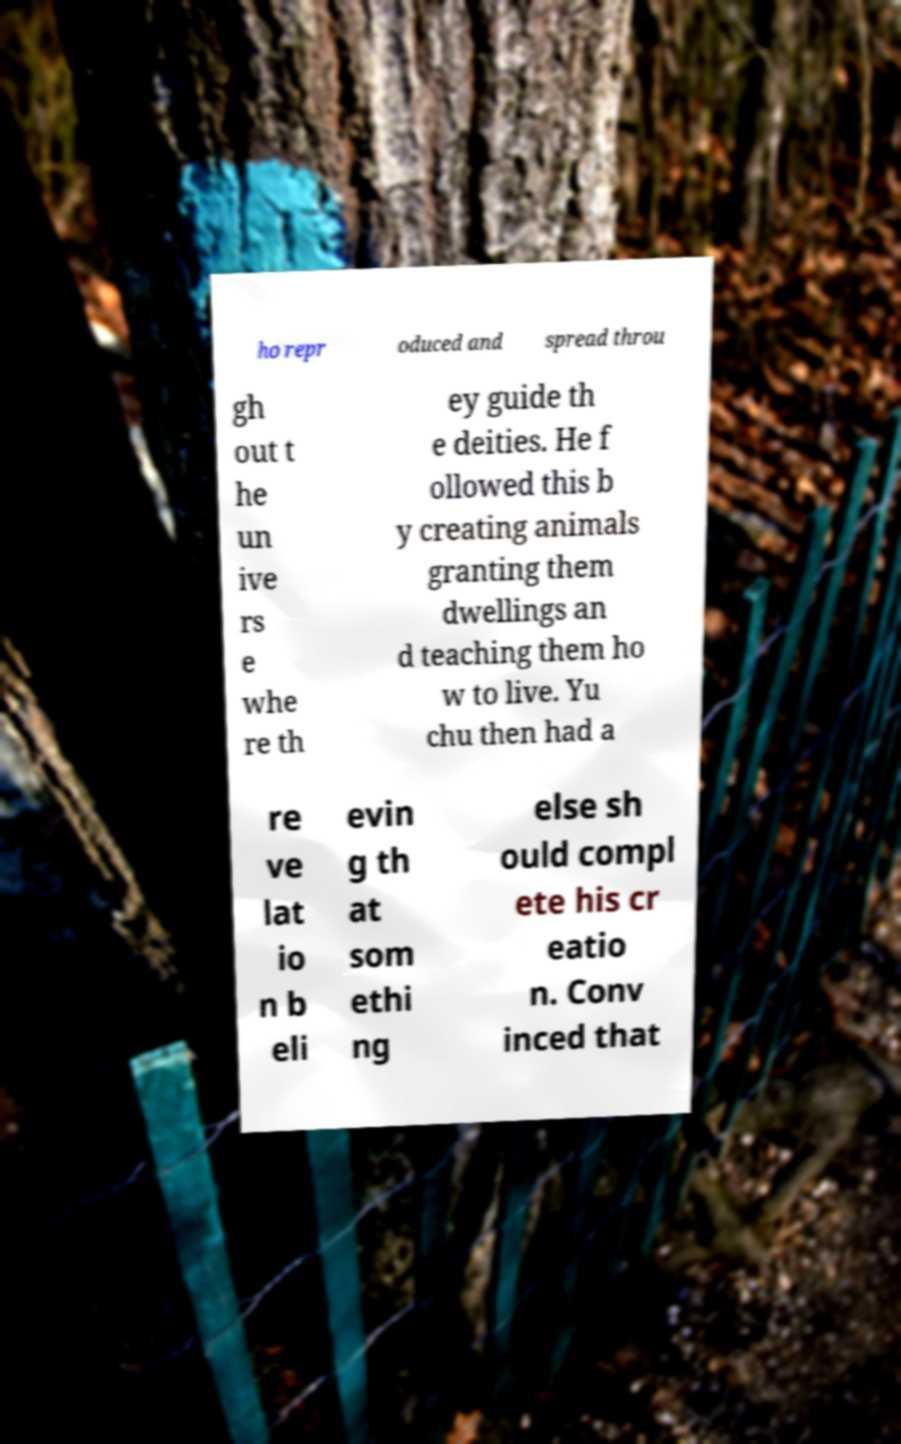What messages or text are displayed in this image? I need them in a readable, typed format. ho repr oduced and spread throu gh out t he un ive rs e whe re th ey guide th e deities. He f ollowed this b y creating animals granting them dwellings an d teaching them ho w to live. Yu chu then had a re ve lat io n b eli evin g th at som ethi ng else sh ould compl ete his cr eatio n. Conv inced that 